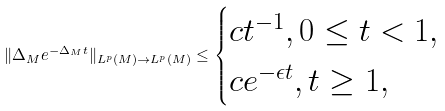Convert formula to latex. <formula><loc_0><loc_0><loc_500><loc_500>\| \Delta _ { M } e ^ { - \Delta _ { M } t } \| _ { L ^ { p } ( M ) \rightarrow L ^ { p } ( M ) } \leq \begin{cases} c t ^ { - 1 } , 0 \leq t < 1 , \\ c e ^ { - \epsilon t } , t \geq 1 , \end{cases}</formula> 